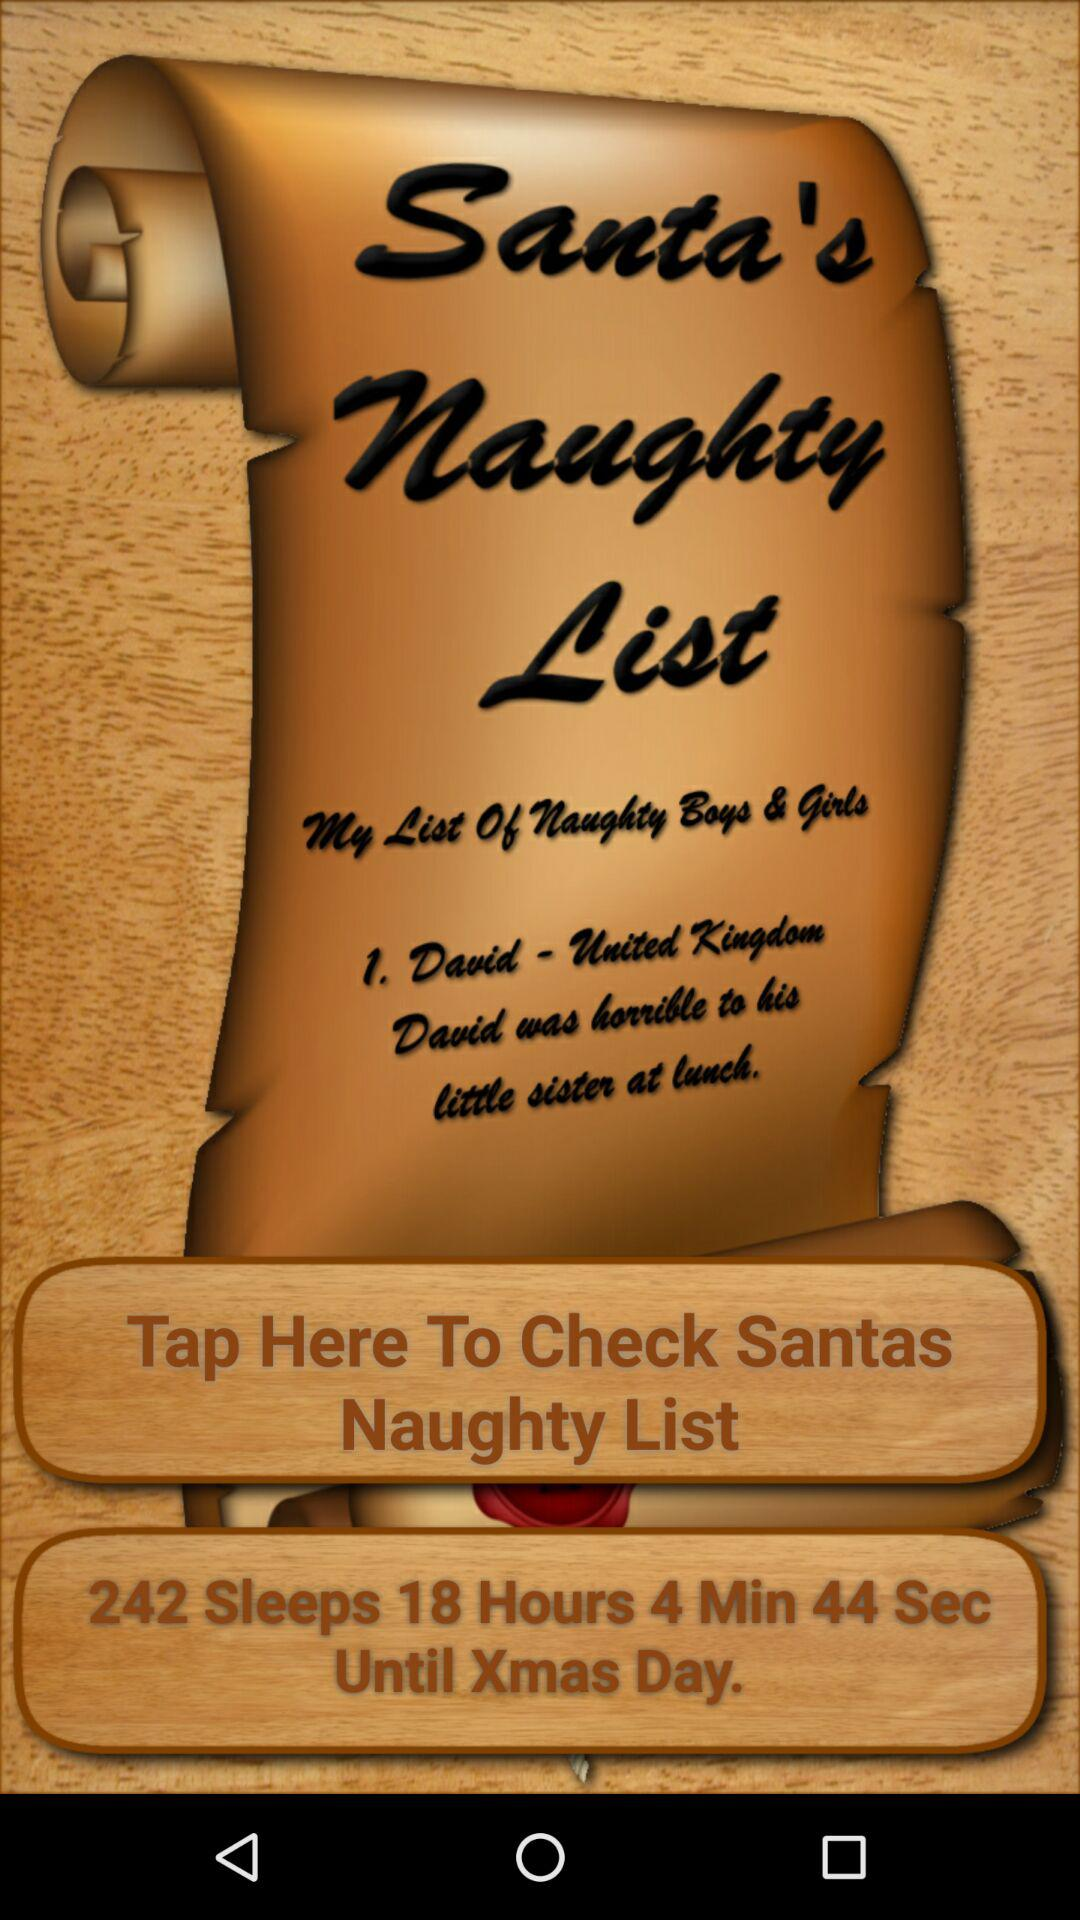What is the given number of slumbers?
When the provided information is insufficient, respond with <no answer>. <no answer> 